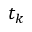Convert formula to latex. <formula><loc_0><loc_0><loc_500><loc_500>t _ { k }</formula> 